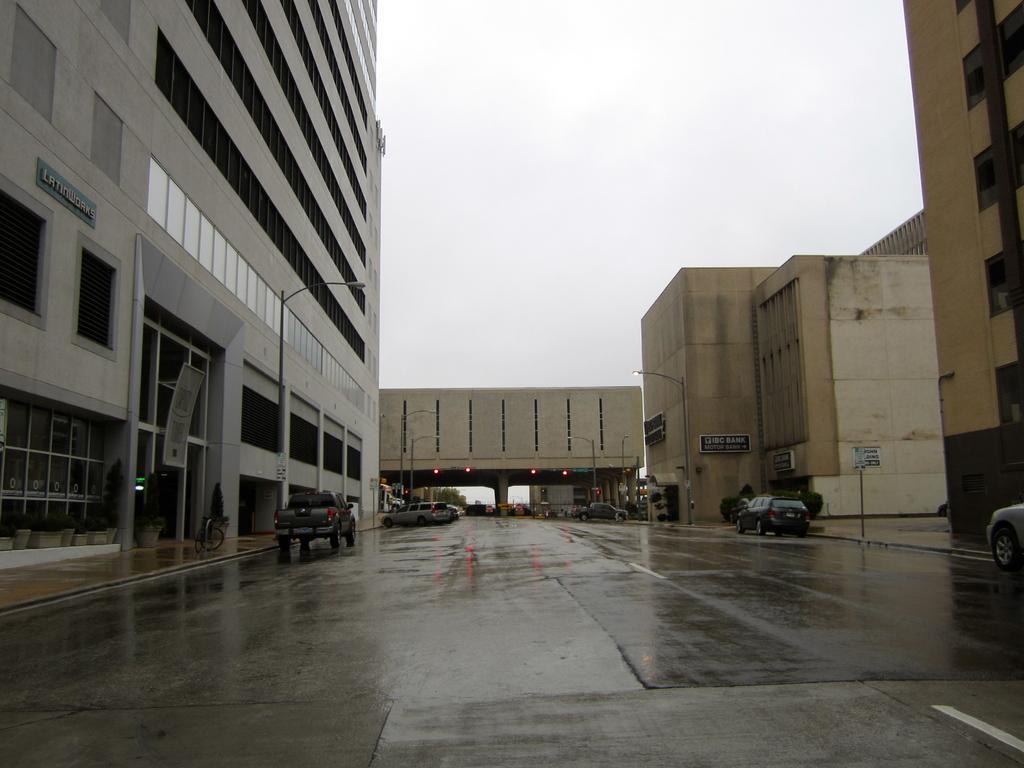Could you give a brief overview of what you see in this image? There is a road. On the sides of the road there are vehicles. There are many buildings on the sides. In the background there is a building with pillars. Also there is sky in the background. 